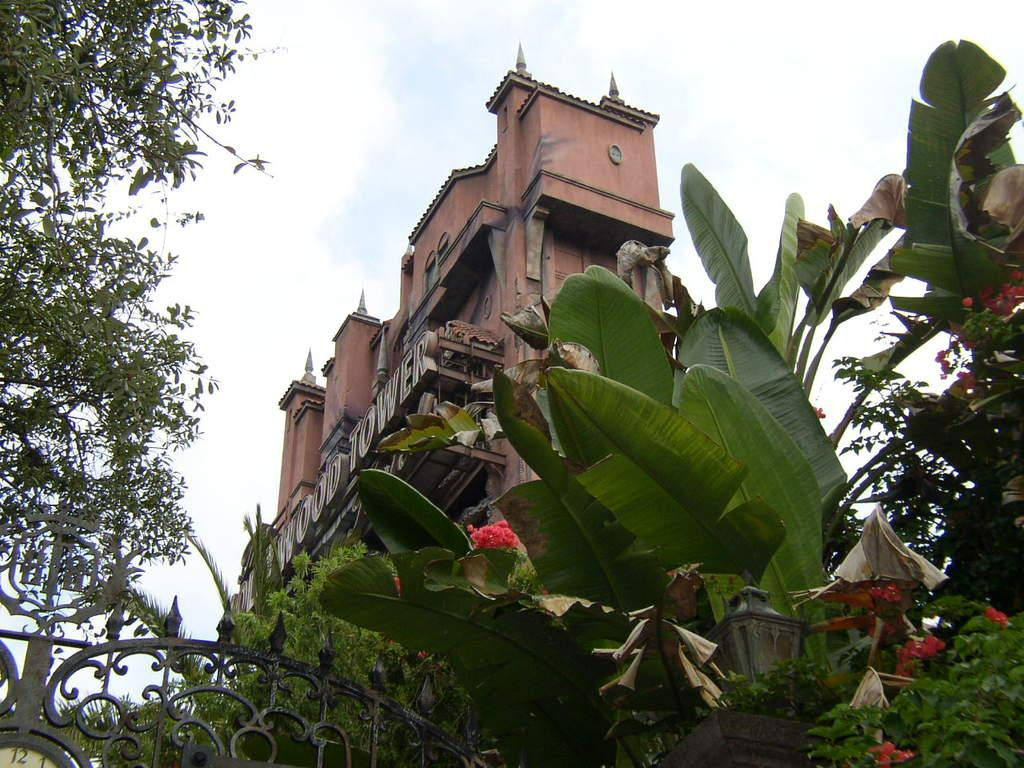What structure can be seen in the image? There is a gate in the image. What type of vegetation is present at the bottom of the image? Trees are present at the bottom of the image. What type of structure is located in the middle of the image? There is a building in the middle of the image. What can be seen in the background of the image? The sky is visible in the background of the image. Can you tell me how many chess pieces are on the gate? There are no chess pieces present in the image; it features a gate, trees, a building, and the sky. What type of jeans is the building wearing in the image? Buildings do not wear jeans; the image features a building, but it is not wearing any clothing. 